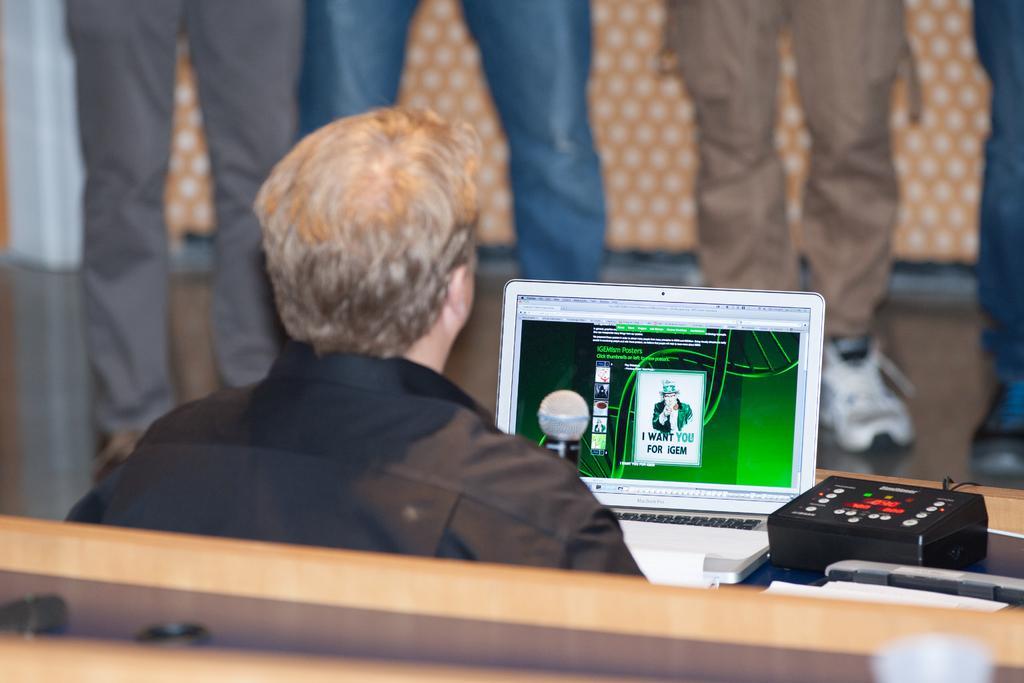Please provide a concise description of this image. In this image we can see the person sitting and in front of him there is the laptop and mic and on the side there is the meter box and papers. And at the back there is the wood and there are people standing. And at the back it looks like a cloth. 